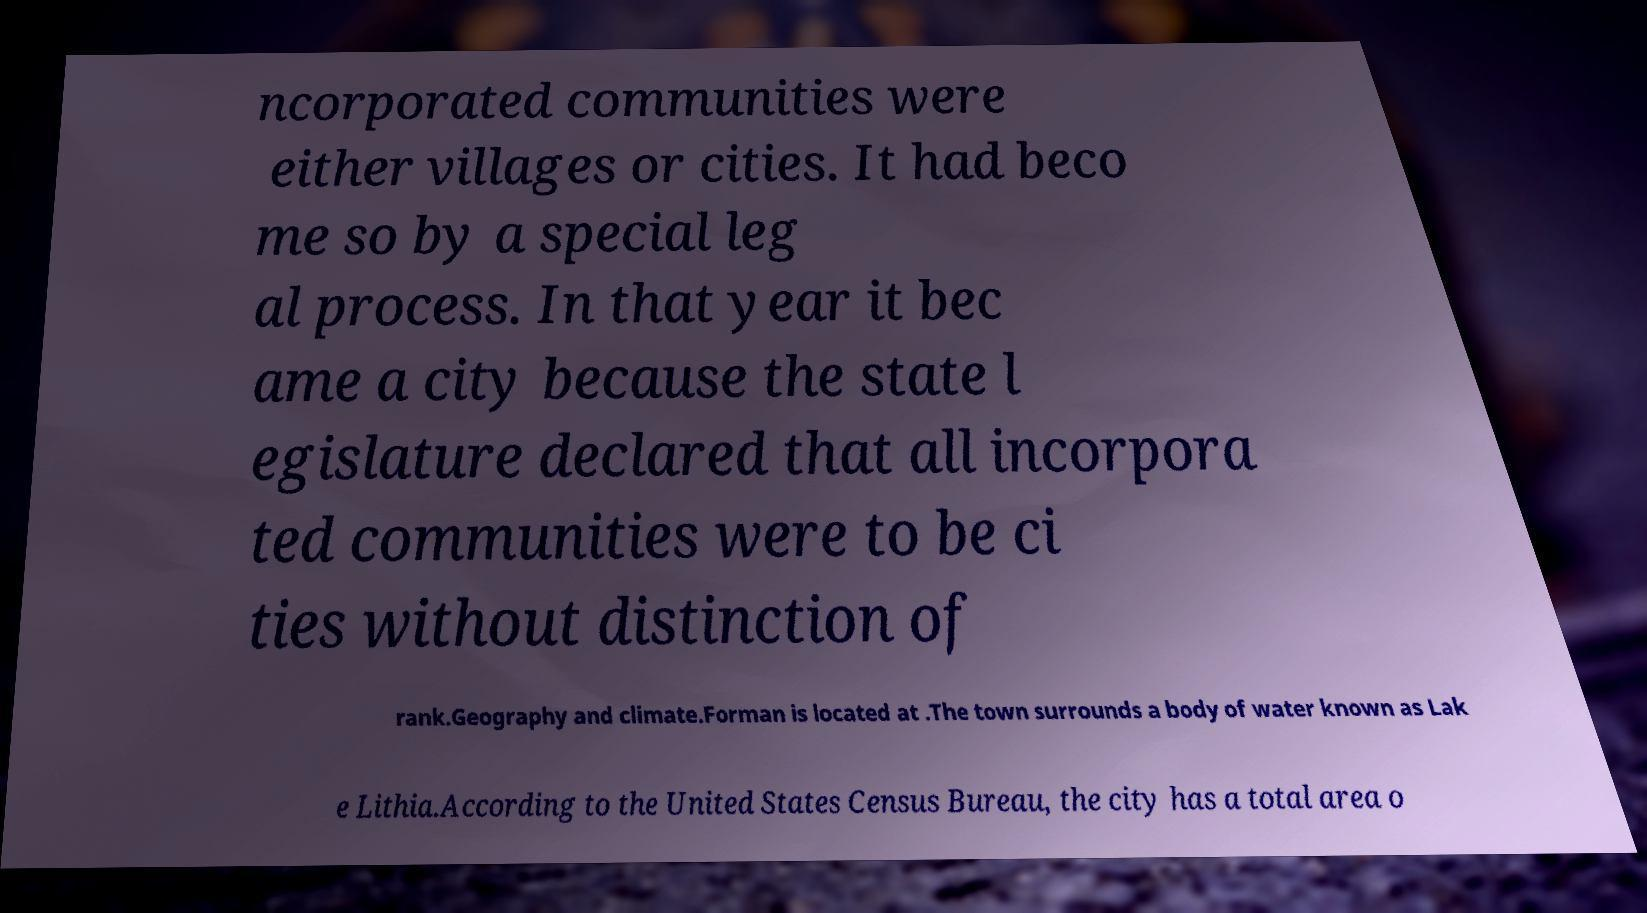There's text embedded in this image that I need extracted. Can you transcribe it verbatim? ncorporated communities were either villages or cities. It had beco me so by a special leg al process. In that year it bec ame a city because the state l egislature declared that all incorpora ted communities were to be ci ties without distinction of rank.Geography and climate.Forman is located at .The town surrounds a body of water known as Lak e Lithia.According to the United States Census Bureau, the city has a total area o 